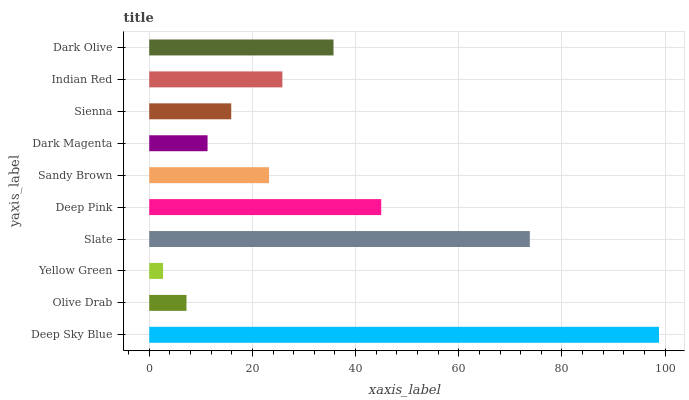Is Yellow Green the minimum?
Answer yes or no. Yes. Is Deep Sky Blue the maximum?
Answer yes or no. Yes. Is Olive Drab the minimum?
Answer yes or no. No. Is Olive Drab the maximum?
Answer yes or no. No. Is Deep Sky Blue greater than Olive Drab?
Answer yes or no. Yes. Is Olive Drab less than Deep Sky Blue?
Answer yes or no. Yes. Is Olive Drab greater than Deep Sky Blue?
Answer yes or no. No. Is Deep Sky Blue less than Olive Drab?
Answer yes or no. No. Is Indian Red the high median?
Answer yes or no. Yes. Is Sandy Brown the low median?
Answer yes or no. Yes. Is Deep Sky Blue the high median?
Answer yes or no. No. Is Dark Magenta the low median?
Answer yes or no. No. 